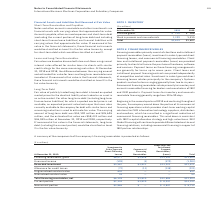According to International Business Machines's financial document, What is the payment term for financing arrangements Payment terms on these financing arrangements are generally for terms up to seven years. Client loans and installment payment financing contracts are priced independently at competitive market rates. The document states: "the purchase of hardware, software and services. Payment terms on these financing arrangements are generally for terms up to seven years. Client loans..." Also, What is the purpose of Client loan and installment payment receivables (loans)? Client loan and installment payment receivables (loans) are provided primarily to clients to finance the purchase of hardware, software and services.. The document states: "cing leases, and commercial financing receivables. Client loan and installment payment receivables (loans) are provided primarily to clients to financ..." Also, What is the payment term for inventory and accounts receivable financing? Payment terms for inventory and accounts receivable financing generally range from 30 to 90 days.. The document states: "r dealers and remarketers of IBM and OEM products. Payment terms for inventory and accounts receivable financing generally range from 30 to 90 days...." Also, can you calculate: What is the average of Total financing receivables, net? To answer this question, I need to perform calculations using the financial data. The calculation is: (6,199+3,820+12,884) / 3, which equals 7634.33 (in millions). This is based on the information: "Total financing receivables, net $6,199 $3,820 $12,884 $22,904 Total financing receivables, net $6,199 $3,820 $12,884 $22,904 Total financing receivables, net $6,199 $3,820 $12,884 $22,904..." The key data points involved are: 12,884, 3,820, 6,199. Also, can you calculate: What is the average of Unearned income? Based on the calculation: 1,083/ 3, the result is 361 (in millions). This is based on the information: "Unearned income (509) (4) (570) (1,083) Unearned income (509) (4) (570) (1,083)..." The key data points involved are: 1,083. Also, can you calculate: What is the average of Recorded investment? To answer this question, I need to perform calculations using the financial data. The calculation is: (5,567+3,831+13,022) / 3, which equals 7473.33 (in millions). This is based on the information: "Recorded investment $5,567 $3,831 $13,022 $22,421 Recorded investment $5,567 $3,831 $13,022 $22,421 Recorded investment $5,567 $3,831 $13,022 $22,421..." The key data points involved are: 13,022, 3,831, 5,567. 